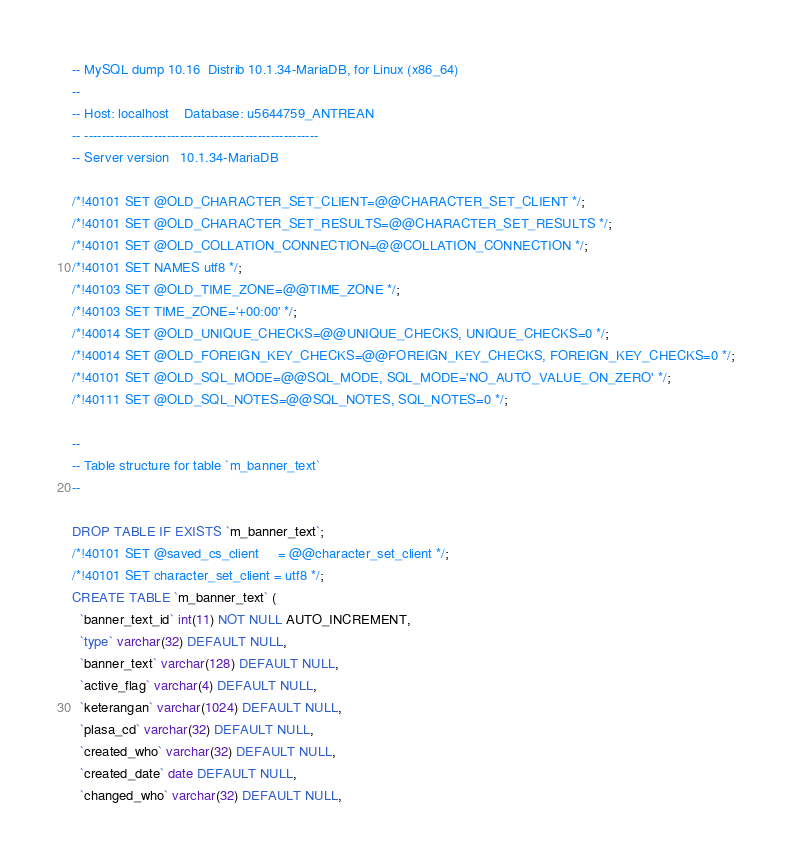<code> <loc_0><loc_0><loc_500><loc_500><_SQL_>-- MySQL dump 10.16  Distrib 10.1.34-MariaDB, for Linux (x86_64)
--
-- Host: localhost    Database: u5644759_ANTREAN
-- ------------------------------------------------------
-- Server version	10.1.34-MariaDB

/*!40101 SET @OLD_CHARACTER_SET_CLIENT=@@CHARACTER_SET_CLIENT */;
/*!40101 SET @OLD_CHARACTER_SET_RESULTS=@@CHARACTER_SET_RESULTS */;
/*!40101 SET @OLD_COLLATION_CONNECTION=@@COLLATION_CONNECTION */;
/*!40101 SET NAMES utf8 */;
/*!40103 SET @OLD_TIME_ZONE=@@TIME_ZONE */;
/*!40103 SET TIME_ZONE='+00:00' */;
/*!40014 SET @OLD_UNIQUE_CHECKS=@@UNIQUE_CHECKS, UNIQUE_CHECKS=0 */;
/*!40014 SET @OLD_FOREIGN_KEY_CHECKS=@@FOREIGN_KEY_CHECKS, FOREIGN_KEY_CHECKS=0 */;
/*!40101 SET @OLD_SQL_MODE=@@SQL_MODE, SQL_MODE='NO_AUTO_VALUE_ON_ZERO' */;
/*!40111 SET @OLD_SQL_NOTES=@@SQL_NOTES, SQL_NOTES=0 */;

--
-- Table structure for table `m_banner_text`
--

DROP TABLE IF EXISTS `m_banner_text`;
/*!40101 SET @saved_cs_client     = @@character_set_client */;
/*!40101 SET character_set_client = utf8 */;
CREATE TABLE `m_banner_text` (
  `banner_text_id` int(11) NOT NULL AUTO_INCREMENT,
  `type` varchar(32) DEFAULT NULL,
  `banner_text` varchar(128) DEFAULT NULL,
  `active_flag` varchar(4) DEFAULT NULL,
  `keterangan` varchar(1024) DEFAULT NULL,
  `plasa_cd` varchar(32) DEFAULT NULL,
  `created_who` varchar(32) DEFAULT NULL,
  `created_date` date DEFAULT NULL,
  `changed_who` varchar(32) DEFAULT NULL,</code> 